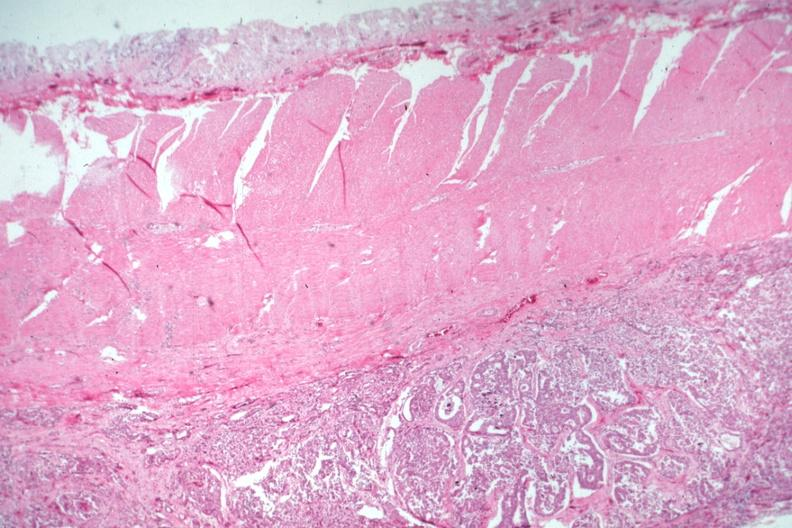s colon present?
Answer the question using a single word or phrase. Yes 